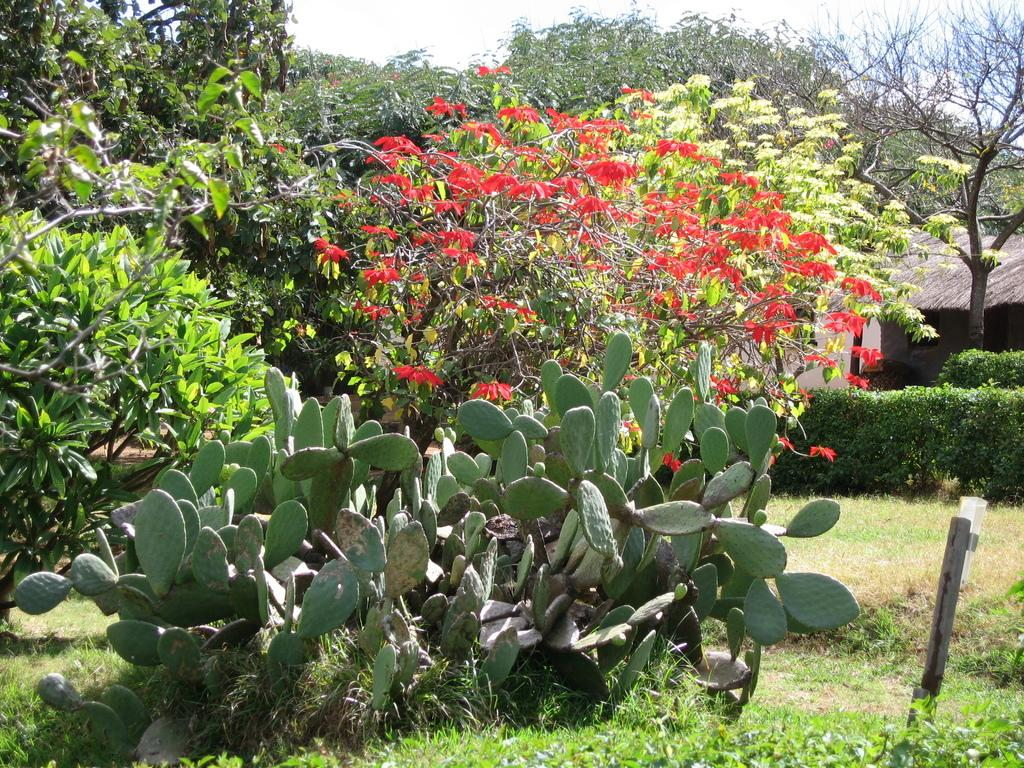What type of vegetation can be seen in the image? There are trees and desert plants visible in the image. Where are the desert plants located in the image? The desert plants are at the bottom of the image. What is visible at the top of the image? The sky is visible at the top of the image. Can you see anyone spying on the trees in the image? There is no indication of anyone spying on the trees in the image. 